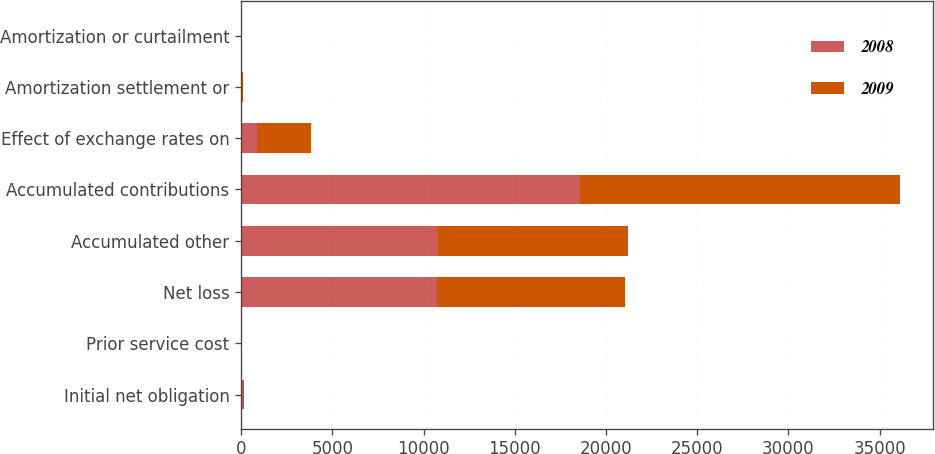Convert chart to OTSL. <chart><loc_0><loc_0><loc_500><loc_500><stacked_bar_chart><ecel><fcel>Initial net obligation<fcel>Prior service cost<fcel>Net loss<fcel>Accumulated other<fcel>Accumulated contributions<fcel>Effect of exchange rates on<fcel>Amortization settlement or<fcel>Amortization or curtailment<nl><fcel>2008<fcel>93<fcel>1<fcel>10720<fcel>10814<fcel>18590<fcel>843<fcel>40<fcel>5<nl><fcel>2009<fcel>58<fcel>7<fcel>10344<fcel>10409<fcel>17509<fcel>2964<fcel>44<fcel>9<nl></chart> 